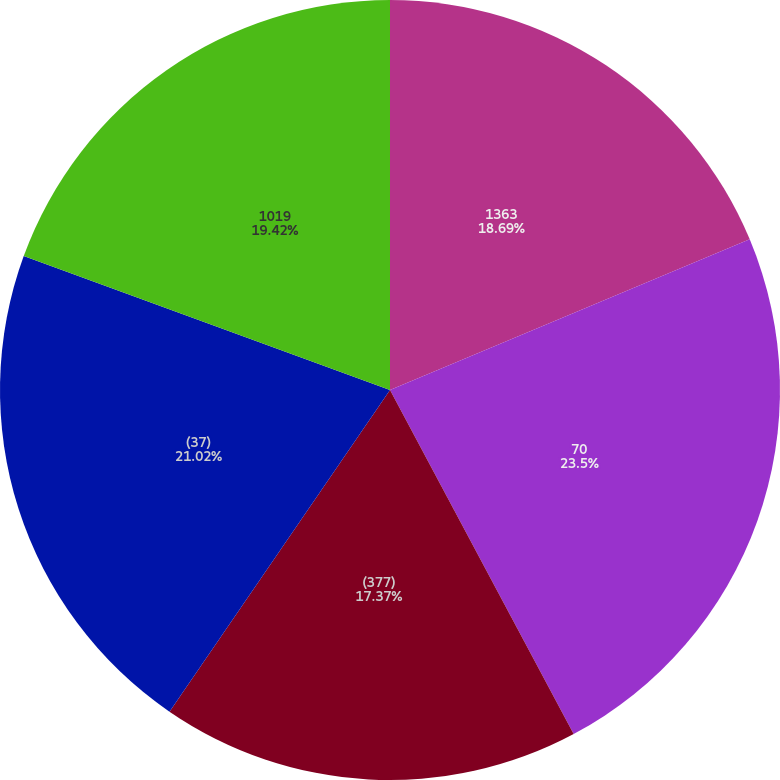Convert chart to OTSL. <chart><loc_0><loc_0><loc_500><loc_500><pie_chart><fcel>1363<fcel>70<fcel>(377)<fcel>(37)<fcel>1019<nl><fcel>18.69%<fcel>23.51%<fcel>17.37%<fcel>21.02%<fcel>19.42%<nl></chart> 